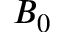Convert formula to latex. <formula><loc_0><loc_0><loc_500><loc_500>B _ { 0 }</formula> 